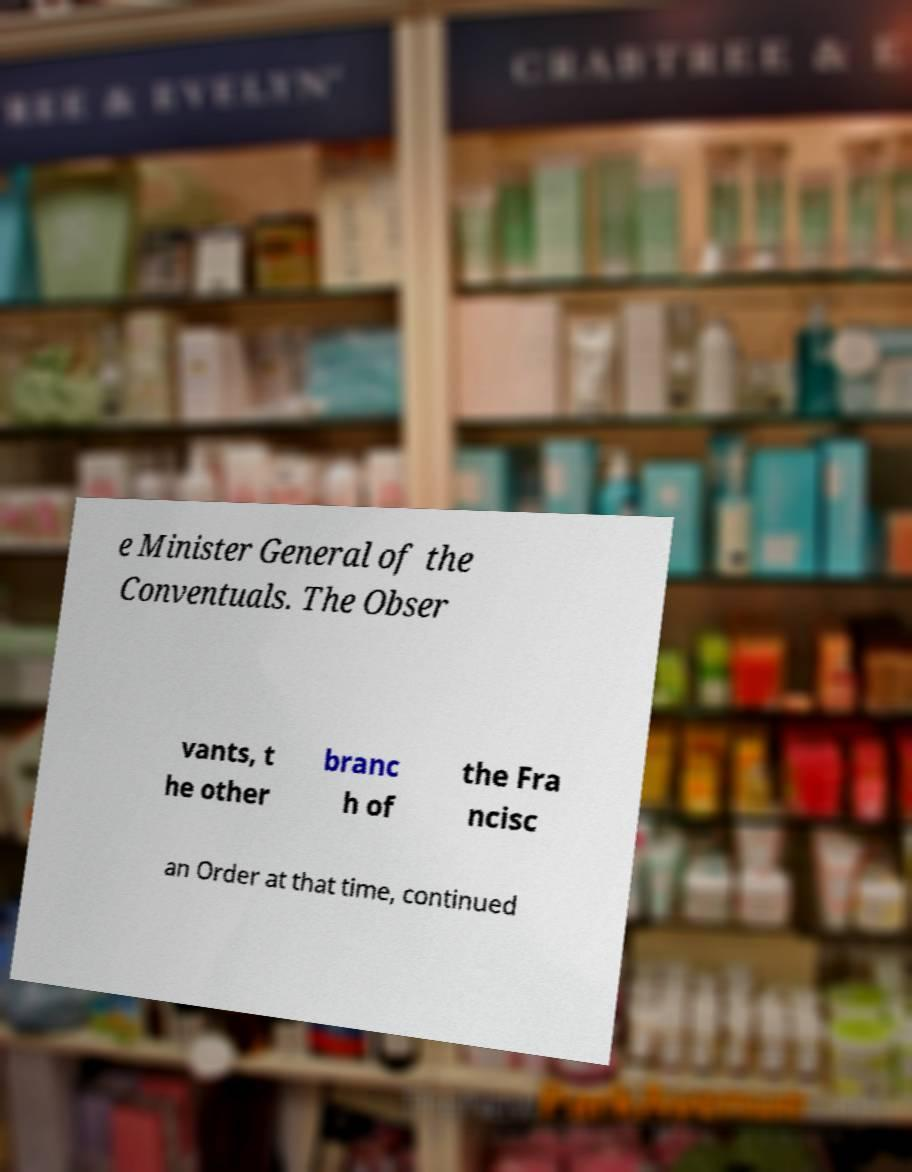I need the written content from this picture converted into text. Can you do that? e Minister General of the Conventuals. The Obser vants, t he other branc h of the Fra ncisc an Order at that time, continued 